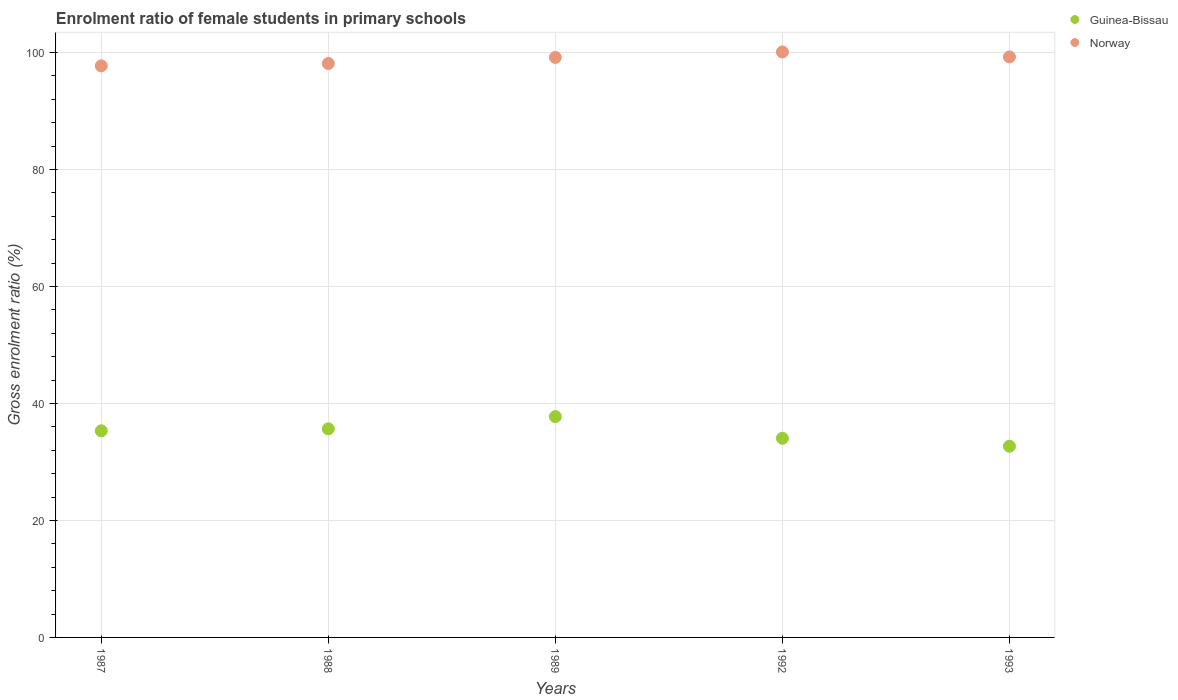How many different coloured dotlines are there?
Offer a terse response. 2. Is the number of dotlines equal to the number of legend labels?
Ensure brevity in your answer.  Yes. What is the enrolment ratio of female students in primary schools in Norway in 1987?
Your response must be concise. 97.72. Across all years, what is the maximum enrolment ratio of female students in primary schools in Guinea-Bissau?
Ensure brevity in your answer.  37.75. Across all years, what is the minimum enrolment ratio of female students in primary schools in Norway?
Make the answer very short. 97.72. In which year was the enrolment ratio of female students in primary schools in Guinea-Bissau minimum?
Provide a short and direct response. 1993. What is the total enrolment ratio of female students in primary schools in Guinea-Bissau in the graph?
Keep it short and to the point. 175.47. What is the difference between the enrolment ratio of female students in primary schools in Norway in 1989 and that in 1993?
Keep it short and to the point. -0.08. What is the difference between the enrolment ratio of female students in primary schools in Norway in 1993 and the enrolment ratio of female students in primary schools in Guinea-Bissau in 1987?
Ensure brevity in your answer.  63.92. What is the average enrolment ratio of female students in primary schools in Norway per year?
Keep it short and to the point. 98.87. In the year 1992, what is the difference between the enrolment ratio of female students in primary schools in Guinea-Bissau and enrolment ratio of female students in primary schools in Norway?
Provide a short and direct response. -66.05. In how many years, is the enrolment ratio of female students in primary schools in Guinea-Bissau greater than 92 %?
Make the answer very short. 0. What is the ratio of the enrolment ratio of female students in primary schools in Guinea-Bissau in 1992 to that in 1993?
Ensure brevity in your answer.  1.04. Is the enrolment ratio of female students in primary schools in Guinea-Bissau in 1988 less than that in 1989?
Offer a terse response. Yes. What is the difference between the highest and the second highest enrolment ratio of female students in primary schools in Norway?
Ensure brevity in your answer.  0.85. What is the difference between the highest and the lowest enrolment ratio of female students in primary schools in Norway?
Offer a terse response. 2.37. In how many years, is the enrolment ratio of female students in primary schools in Norway greater than the average enrolment ratio of female students in primary schools in Norway taken over all years?
Provide a succinct answer. 3. Is the sum of the enrolment ratio of female students in primary schools in Norway in 1987 and 1993 greater than the maximum enrolment ratio of female students in primary schools in Guinea-Bissau across all years?
Your answer should be very brief. Yes. Does the enrolment ratio of female students in primary schools in Norway monotonically increase over the years?
Provide a short and direct response. No. Is the enrolment ratio of female students in primary schools in Guinea-Bissau strictly less than the enrolment ratio of female students in primary schools in Norway over the years?
Offer a terse response. Yes. How many dotlines are there?
Provide a succinct answer. 2. Are the values on the major ticks of Y-axis written in scientific E-notation?
Your response must be concise. No. Does the graph contain any zero values?
Offer a terse response. No. Does the graph contain grids?
Give a very brief answer. Yes. Where does the legend appear in the graph?
Provide a short and direct response. Top right. What is the title of the graph?
Give a very brief answer. Enrolment ratio of female students in primary schools. Does "Guatemala" appear as one of the legend labels in the graph?
Offer a terse response. No. What is the label or title of the X-axis?
Your answer should be compact. Years. What is the label or title of the Y-axis?
Offer a terse response. Gross enrolment ratio (%). What is the Gross enrolment ratio (%) of Guinea-Bissau in 1987?
Your answer should be very brief. 35.33. What is the Gross enrolment ratio (%) in Norway in 1987?
Offer a very short reply. 97.72. What is the Gross enrolment ratio (%) of Guinea-Bissau in 1988?
Ensure brevity in your answer.  35.66. What is the Gross enrolment ratio (%) in Norway in 1988?
Make the answer very short. 98.12. What is the Gross enrolment ratio (%) in Guinea-Bissau in 1989?
Your answer should be very brief. 37.75. What is the Gross enrolment ratio (%) of Norway in 1989?
Keep it short and to the point. 99.16. What is the Gross enrolment ratio (%) of Guinea-Bissau in 1992?
Give a very brief answer. 34.05. What is the Gross enrolment ratio (%) of Norway in 1992?
Your answer should be compact. 100.09. What is the Gross enrolment ratio (%) in Guinea-Bissau in 1993?
Give a very brief answer. 32.68. What is the Gross enrolment ratio (%) of Norway in 1993?
Your answer should be very brief. 99.24. Across all years, what is the maximum Gross enrolment ratio (%) of Guinea-Bissau?
Offer a very short reply. 37.75. Across all years, what is the maximum Gross enrolment ratio (%) in Norway?
Provide a succinct answer. 100.09. Across all years, what is the minimum Gross enrolment ratio (%) in Guinea-Bissau?
Make the answer very short. 32.68. Across all years, what is the minimum Gross enrolment ratio (%) of Norway?
Make the answer very short. 97.72. What is the total Gross enrolment ratio (%) of Guinea-Bissau in the graph?
Ensure brevity in your answer.  175.47. What is the total Gross enrolment ratio (%) of Norway in the graph?
Your answer should be very brief. 494.34. What is the difference between the Gross enrolment ratio (%) of Guinea-Bissau in 1987 and that in 1988?
Your answer should be very brief. -0.34. What is the difference between the Gross enrolment ratio (%) in Norway in 1987 and that in 1988?
Provide a succinct answer. -0.4. What is the difference between the Gross enrolment ratio (%) in Guinea-Bissau in 1987 and that in 1989?
Give a very brief answer. -2.42. What is the difference between the Gross enrolment ratio (%) in Norway in 1987 and that in 1989?
Give a very brief answer. -1.44. What is the difference between the Gross enrolment ratio (%) in Guinea-Bissau in 1987 and that in 1992?
Ensure brevity in your answer.  1.28. What is the difference between the Gross enrolment ratio (%) of Norway in 1987 and that in 1992?
Offer a very short reply. -2.37. What is the difference between the Gross enrolment ratio (%) in Guinea-Bissau in 1987 and that in 1993?
Your answer should be very brief. 2.64. What is the difference between the Gross enrolment ratio (%) of Norway in 1987 and that in 1993?
Your answer should be very brief. -1.52. What is the difference between the Gross enrolment ratio (%) of Guinea-Bissau in 1988 and that in 1989?
Give a very brief answer. -2.08. What is the difference between the Gross enrolment ratio (%) of Norway in 1988 and that in 1989?
Give a very brief answer. -1.05. What is the difference between the Gross enrolment ratio (%) in Guinea-Bissau in 1988 and that in 1992?
Provide a succinct answer. 1.62. What is the difference between the Gross enrolment ratio (%) of Norway in 1988 and that in 1992?
Your answer should be compact. -1.98. What is the difference between the Gross enrolment ratio (%) in Guinea-Bissau in 1988 and that in 1993?
Provide a short and direct response. 2.98. What is the difference between the Gross enrolment ratio (%) of Norway in 1988 and that in 1993?
Ensure brevity in your answer.  -1.13. What is the difference between the Gross enrolment ratio (%) in Guinea-Bissau in 1989 and that in 1992?
Provide a succinct answer. 3.7. What is the difference between the Gross enrolment ratio (%) of Norway in 1989 and that in 1992?
Ensure brevity in your answer.  -0.93. What is the difference between the Gross enrolment ratio (%) in Guinea-Bissau in 1989 and that in 1993?
Your answer should be compact. 5.06. What is the difference between the Gross enrolment ratio (%) of Norway in 1989 and that in 1993?
Keep it short and to the point. -0.08. What is the difference between the Gross enrolment ratio (%) of Guinea-Bissau in 1992 and that in 1993?
Provide a succinct answer. 1.36. What is the difference between the Gross enrolment ratio (%) in Guinea-Bissau in 1987 and the Gross enrolment ratio (%) in Norway in 1988?
Your answer should be compact. -62.79. What is the difference between the Gross enrolment ratio (%) in Guinea-Bissau in 1987 and the Gross enrolment ratio (%) in Norway in 1989?
Make the answer very short. -63.84. What is the difference between the Gross enrolment ratio (%) in Guinea-Bissau in 1987 and the Gross enrolment ratio (%) in Norway in 1992?
Give a very brief answer. -64.77. What is the difference between the Gross enrolment ratio (%) of Guinea-Bissau in 1987 and the Gross enrolment ratio (%) of Norway in 1993?
Your answer should be compact. -63.92. What is the difference between the Gross enrolment ratio (%) in Guinea-Bissau in 1988 and the Gross enrolment ratio (%) in Norway in 1989?
Give a very brief answer. -63.5. What is the difference between the Gross enrolment ratio (%) in Guinea-Bissau in 1988 and the Gross enrolment ratio (%) in Norway in 1992?
Ensure brevity in your answer.  -64.43. What is the difference between the Gross enrolment ratio (%) in Guinea-Bissau in 1988 and the Gross enrolment ratio (%) in Norway in 1993?
Your answer should be very brief. -63.58. What is the difference between the Gross enrolment ratio (%) of Guinea-Bissau in 1989 and the Gross enrolment ratio (%) of Norway in 1992?
Your answer should be compact. -62.35. What is the difference between the Gross enrolment ratio (%) in Guinea-Bissau in 1989 and the Gross enrolment ratio (%) in Norway in 1993?
Provide a short and direct response. -61.5. What is the difference between the Gross enrolment ratio (%) of Guinea-Bissau in 1992 and the Gross enrolment ratio (%) of Norway in 1993?
Your response must be concise. -65.2. What is the average Gross enrolment ratio (%) of Guinea-Bissau per year?
Provide a short and direct response. 35.09. What is the average Gross enrolment ratio (%) in Norway per year?
Give a very brief answer. 98.87. In the year 1987, what is the difference between the Gross enrolment ratio (%) in Guinea-Bissau and Gross enrolment ratio (%) in Norway?
Ensure brevity in your answer.  -62.4. In the year 1988, what is the difference between the Gross enrolment ratio (%) in Guinea-Bissau and Gross enrolment ratio (%) in Norway?
Your answer should be compact. -62.45. In the year 1989, what is the difference between the Gross enrolment ratio (%) in Guinea-Bissau and Gross enrolment ratio (%) in Norway?
Keep it short and to the point. -61.42. In the year 1992, what is the difference between the Gross enrolment ratio (%) of Guinea-Bissau and Gross enrolment ratio (%) of Norway?
Offer a terse response. -66.05. In the year 1993, what is the difference between the Gross enrolment ratio (%) in Guinea-Bissau and Gross enrolment ratio (%) in Norway?
Keep it short and to the point. -66.56. What is the ratio of the Gross enrolment ratio (%) in Guinea-Bissau in 1987 to that in 1988?
Offer a terse response. 0.99. What is the ratio of the Gross enrolment ratio (%) in Norway in 1987 to that in 1988?
Ensure brevity in your answer.  1. What is the ratio of the Gross enrolment ratio (%) of Guinea-Bissau in 1987 to that in 1989?
Offer a very short reply. 0.94. What is the ratio of the Gross enrolment ratio (%) of Norway in 1987 to that in 1989?
Make the answer very short. 0.99. What is the ratio of the Gross enrolment ratio (%) of Guinea-Bissau in 1987 to that in 1992?
Make the answer very short. 1.04. What is the ratio of the Gross enrolment ratio (%) of Norway in 1987 to that in 1992?
Ensure brevity in your answer.  0.98. What is the ratio of the Gross enrolment ratio (%) in Guinea-Bissau in 1987 to that in 1993?
Your answer should be very brief. 1.08. What is the ratio of the Gross enrolment ratio (%) of Norway in 1987 to that in 1993?
Keep it short and to the point. 0.98. What is the ratio of the Gross enrolment ratio (%) in Guinea-Bissau in 1988 to that in 1989?
Provide a succinct answer. 0.94. What is the ratio of the Gross enrolment ratio (%) of Norway in 1988 to that in 1989?
Your response must be concise. 0.99. What is the ratio of the Gross enrolment ratio (%) in Guinea-Bissau in 1988 to that in 1992?
Offer a very short reply. 1.05. What is the ratio of the Gross enrolment ratio (%) of Norway in 1988 to that in 1992?
Ensure brevity in your answer.  0.98. What is the ratio of the Gross enrolment ratio (%) of Guinea-Bissau in 1988 to that in 1993?
Provide a short and direct response. 1.09. What is the ratio of the Gross enrolment ratio (%) of Norway in 1988 to that in 1993?
Offer a very short reply. 0.99. What is the ratio of the Gross enrolment ratio (%) in Guinea-Bissau in 1989 to that in 1992?
Your answer should be compact. 1.11. What is the ratio of the Gross enrolment ratio (%) of Guinea-Bissau in 1989 to that in 1993?
Make the answer very short. 1.15. What is the ratio of the Gross enrolment ratio (%) of Guinea-Bissau in 1992 to that in 1993?
Your answer should be very brief. 1.04. What is the ratio of the Gross enrolment ratio (%) of Norway in 1992 to that in 1993?
Provide a succinct answer. 1.01. What is the difference between the highest and the second highest Gross enrolment ratio (%) in Guinea-Bissau?
Your response must be concise. 2.08. What is the difference between the highest and the second highest Gross enrolment ratio (%) in Norway?
Provide a succinct answer. 0.85. What is the difference between the highest and the lowest Gross enrolment ratio (%) of Guinea-Bissau?
Your answer should be very brief. 5.06. What is the difference between the highest and the lowest Gross enrolment ratio (%) of Norway?
Provide a succinct answer. 2.37. 